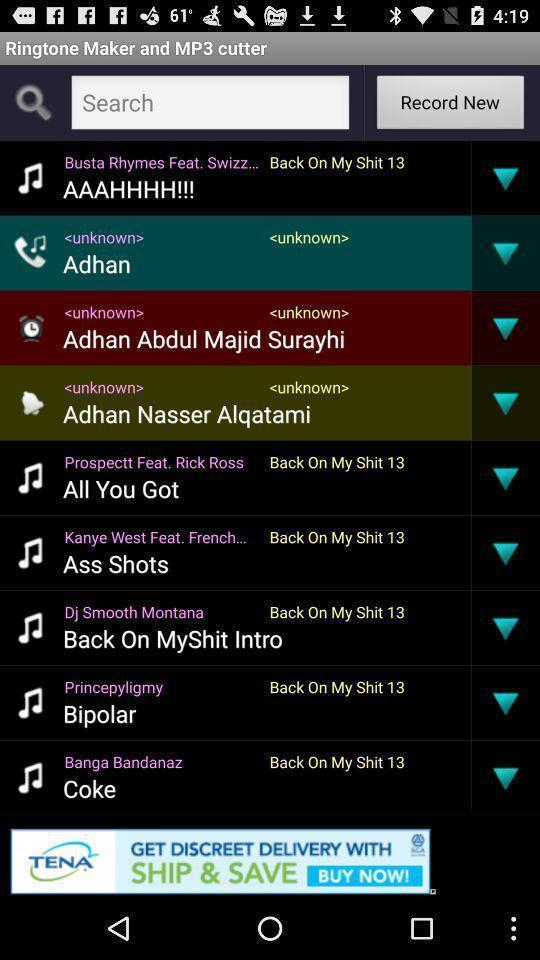Please provide a description for this image. Page displaying the ringtones. 